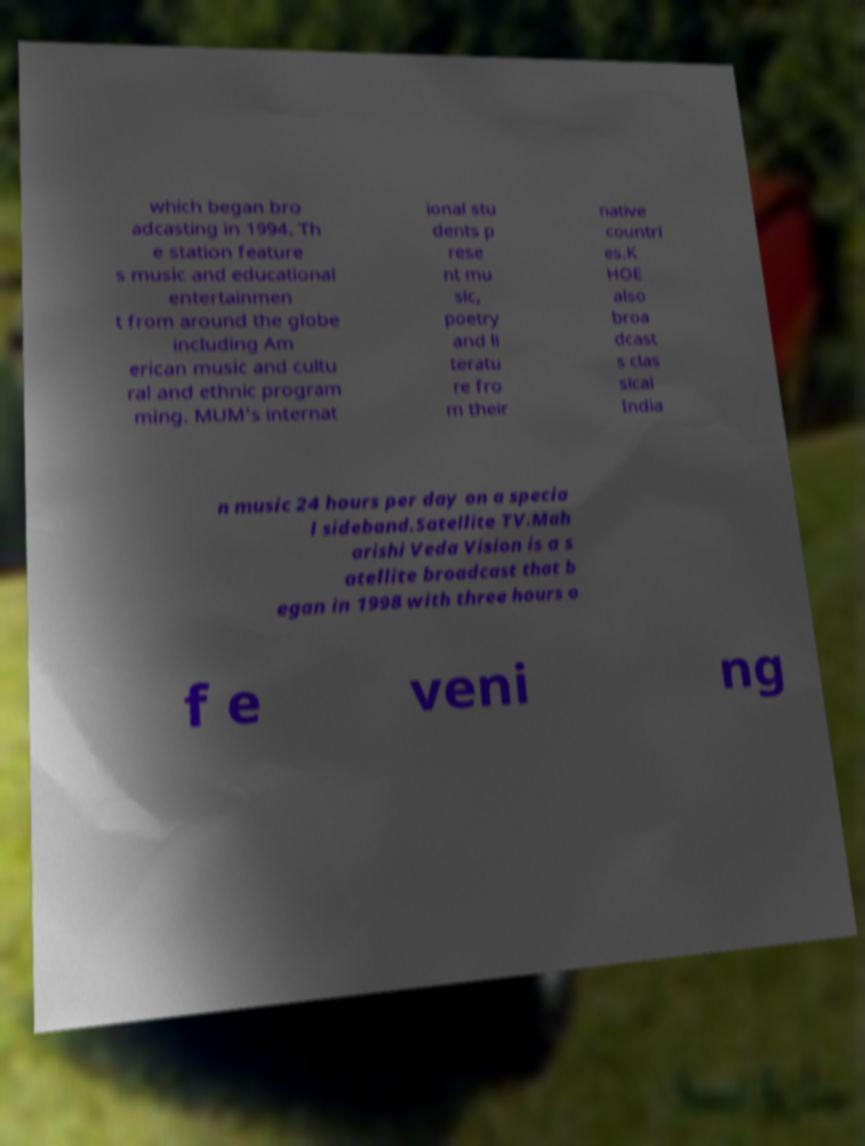Please identify and transcribe the text found in this image. which began bro adcasting in 1994. Th e station feature s music and educational entertainmen t from around the globe including Am erican music and cultu ral and ethnic program ming. MUM's internat ional stu dents p rese nt mu sic, poetry and li teratu re fro m their native countri es.K HOE also broa dcast s clas sical India n music 24 hours per day on a specia l sideband.Satellite TV.Mah arishi Veda Vision is a s atellite broadcast that b egan in 1998 with three hours o f e veni ng 